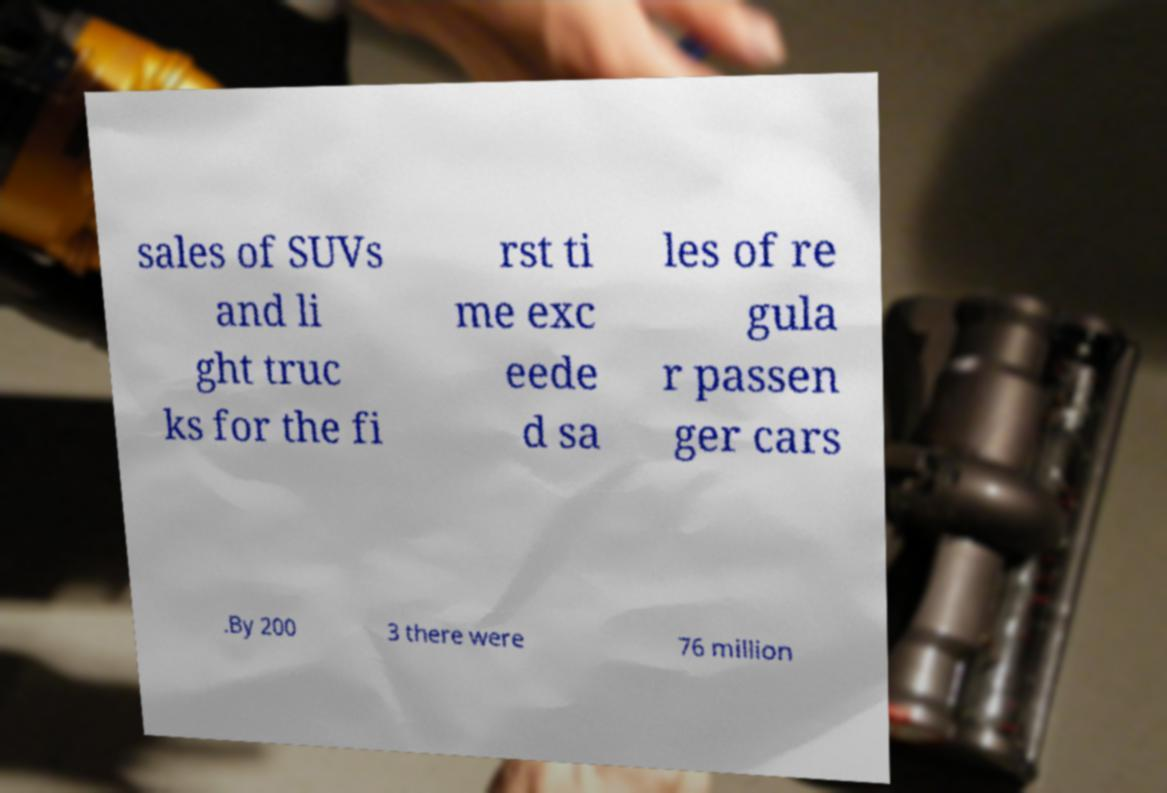Please read and relay the text visible in this image. What does it say? sales of SUVs and li ght truc ks for the fi rst ti me exc eede d sa les of re gula r passen ger cars .By 200 3 there were 76 million 